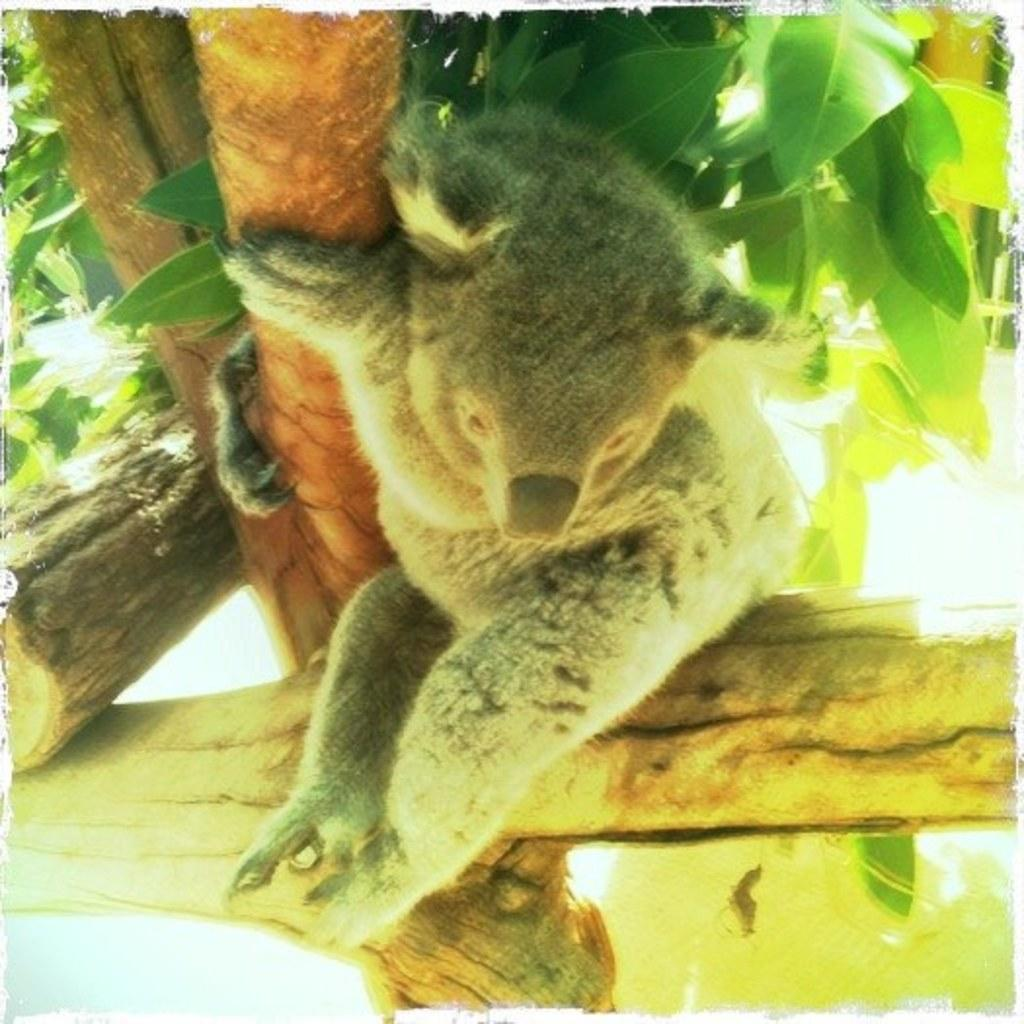What animal is in the foreground of the picture? There is a koala in the foreground of the picture. Where is the koala located? The koala is on a tree. What is the koala holding? The koala is holding a stem. What type of writing can be seen on the tree trunk in the image? There is no writing visible on the tree trunk in the image. 